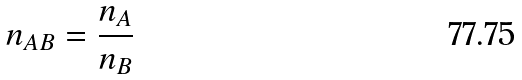<formula> <loc_0><loc_0><loc_500><loc_500>n _ { A B } = \frac { n _ { A } } { n _ { B } }</formula> 